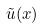<formula> <loc_0><loc_0><loc_500><loc_500>\tilde { u } ( x )</formula> 